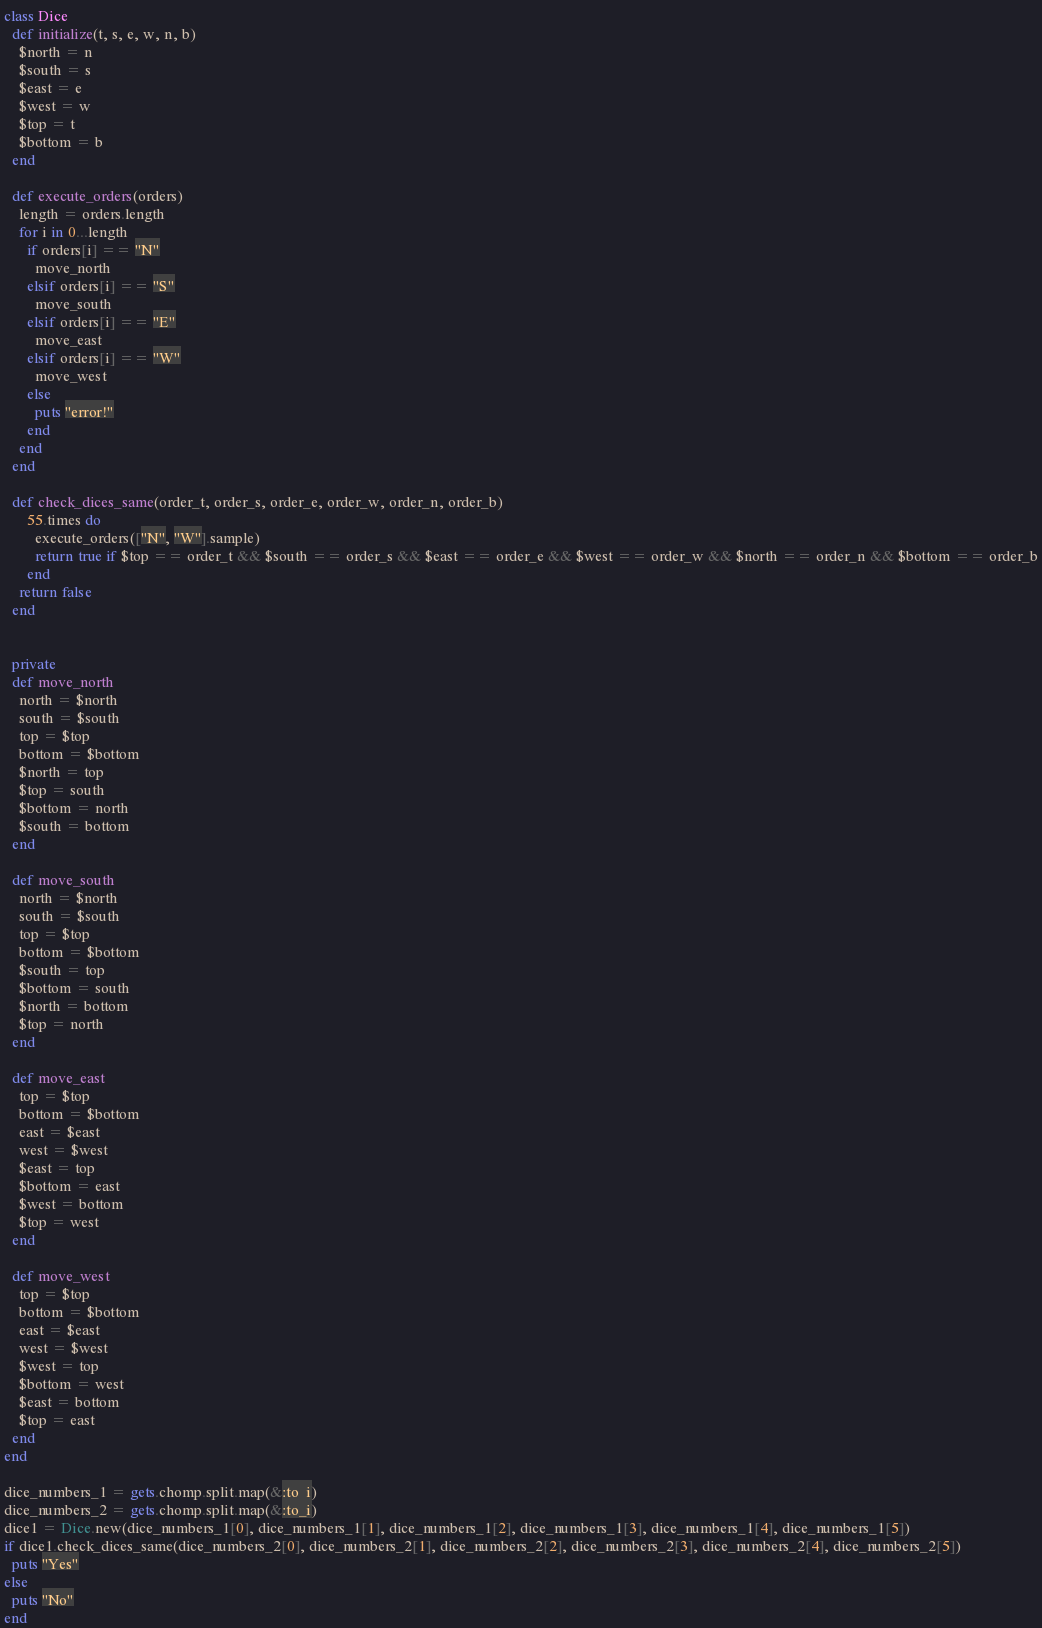Convert code to text. <code><loc_0><loc_0><loc_500><loc_500><_Ruby_>class Dice
  def initialize(t, s, e, w, n, b)
    $north = n
    $south = s
    $east = e
    $west = w
    $top = t
    $bottom = b
  end

  def execute_orders(orders)
    length = orders.length
    for i in 0...length
      if orders[i] == "N"
        move_north
      elsif orders[i] == "S"
        move_south
      elsif orders[i] == "E"
        move_east
      elsif orders[i] == "W"
        move_west
      else
        puts "error!"
      end
    end
  end

  def check_dices_same(order_t, order_s, order_e, order_w, order_n, order_b)
      55.times do
        execute_orders(["N", "W"].sample)
        return true if $top == order_t && $south == order_s && $east == order_e && $west == order_w && $north == order_n && $bottom == order_b
      end
    return false
  end


  private
  def move_north
    north = $north
    south = $south
    top = $top
    bottom = $bottom
    $north = top
    $top = south
    $bottom = north
    $south = bottom
  end

  def move_south
    north = $north
    south = $south
    top = $top
    bottom = $bottom
    $south = top
    $bottom = south
    $north = bottom
    $top = north
  end

  def move_east
    top = $top
    bottom = $bottom
    east = $east
    west = $west
    $east = top
    $bottom = east
    $west = bottom
    $top = west
  end

  def move_west
    top = $top
    bottom = $bottom
    east = $east
    west = $west
    $west = top
    $bottom = west
    $east = bottom
    $top = east
  end
end

dice_numbers_1 = gets.chomp.split.map(&:to_i)
dice_numbers_2 = gets.chomp.split.map(&:to_i)
dice1 = Dice.new(dice_numbers_1[0], dice_numbers_1[1], dice_numbers_1[2], dice_numbers_1[3], dice_numbers_1[4], dice_numbers_1[5])
if dice1.check_dices_same(dice_numbers_2[0], dice_numbers_2[1], dice_numbers_2[2], dice_numbers_2[3], dice_numbers_2[4], dice_numbers_2[5])
  puts "Yes"
else
  puts "No"
end</code> 